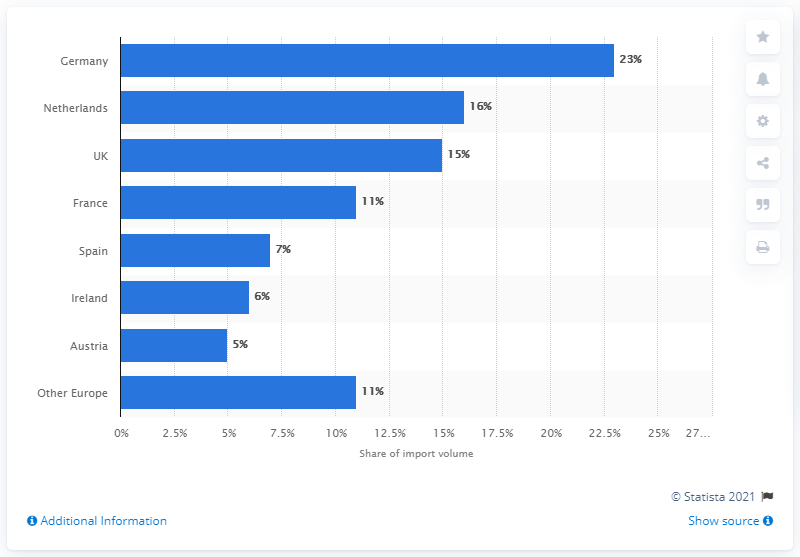List a handful of essential elements in this visual. In 2017, Germany's share of essential oil imports was approximately 23%. In 2017, the volume share of essential oil imports in the Netherlands was 16%. 